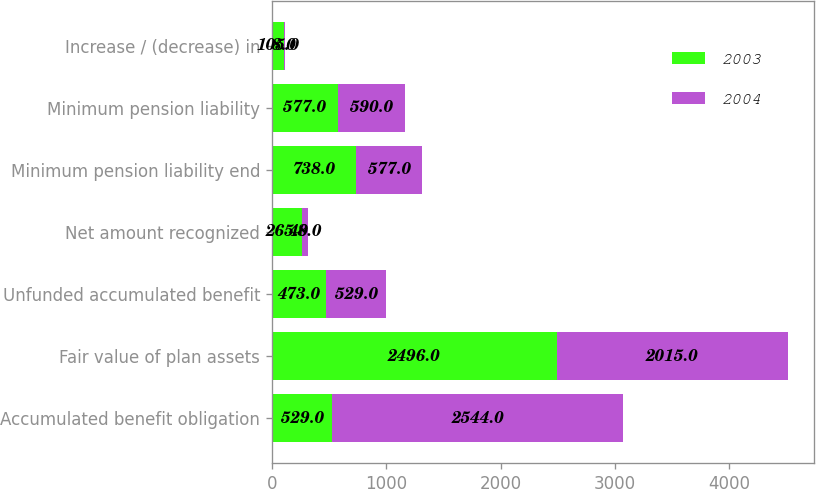Convert chart. <chart><loc_0><loc_0><loc_500><loc_500><stacked_bar_chart><ecel><fcel>Accumulated benefit obligation<fcel>Fair value of plan assets<fcel>Unfunded accumulated benefit<fcel>Net amount recognized<fcel>Minimum pension liability end<fcel>Minimum pension liability<fcel>Increase / (decrease) in<nl><fcel>2003<fcel>529<fcel>2496<fcel>473<fcel>265<fcel>738<fcel>577<fcel>105<nl><fcel>2004<fcel>2544<fcel>2015<fcel>529<fcel>48<fcel>577<fcel>590<fcel>8<nl></chart> 